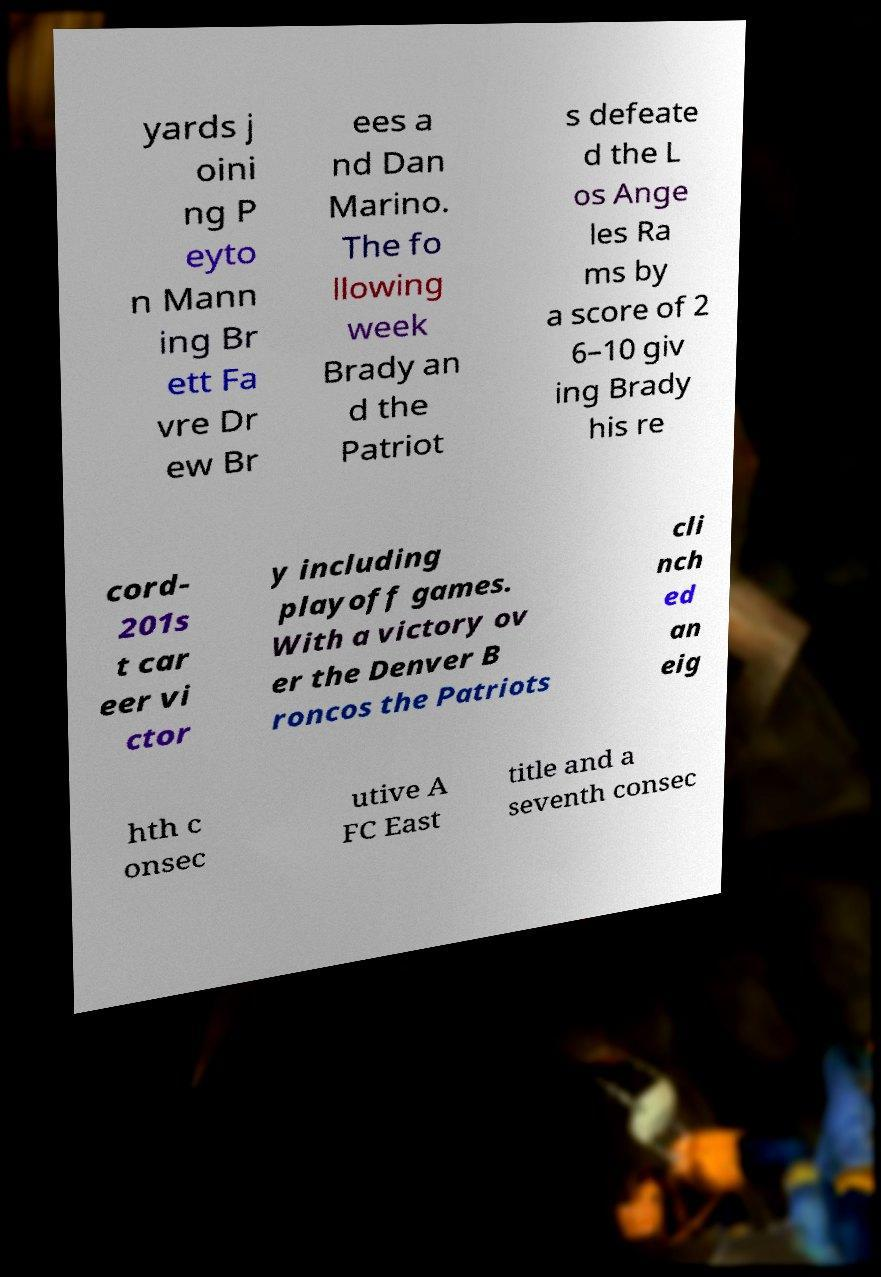Can you accurately transcribe the text from the provided image for me? yards j oini ng P eyto n Mann ing Br ett Fa vre Dr ew Br ees a nd Dan Marino. The fo llowing week Brady an d the Patriot s defeate d the L os Ange les Ra ms by a score of 2 6–10 giv ing Brady his re cord- 201s t car eer vi ctor y including playoff games. With a victory ov er the Denver B roncos the Patriots cli nch ed an eig hth c onsec utive A FC East title and a seventh consec 